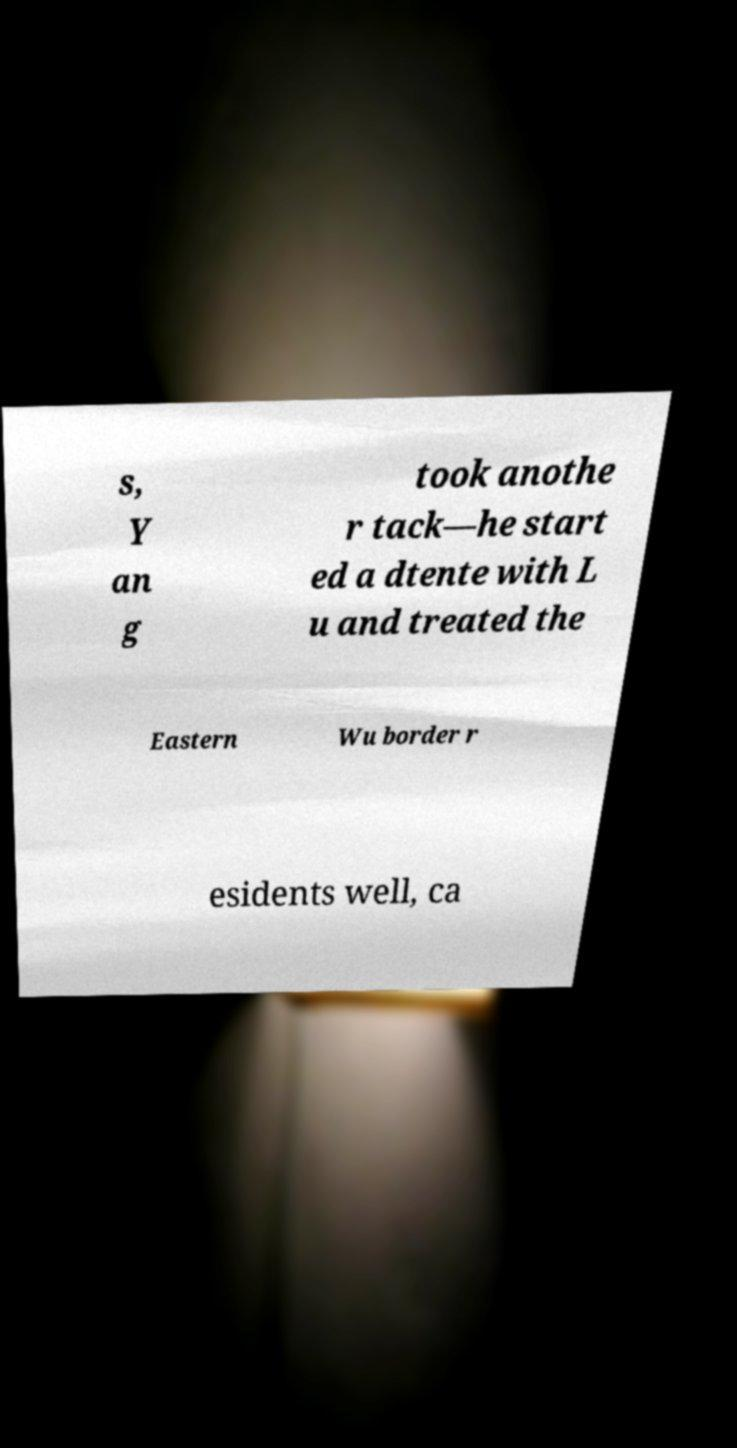There's text embedded in this image that I need extracted. Can you transcribe it verbatim? s, Y an g took anothe r tack—he start ed a dtente with L u and treated the Eastern Wu border r esidents well, ca 